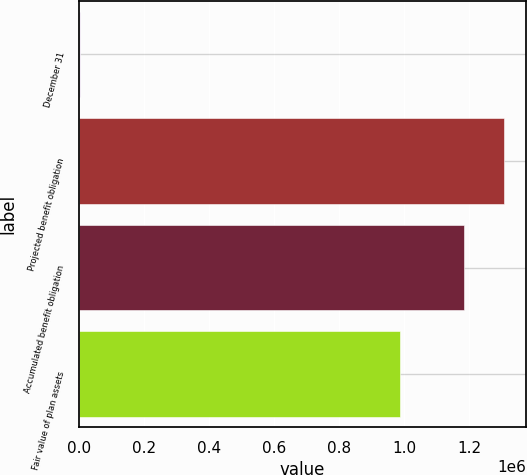Convert chart. <chart><loc_0><loc_0><loc_500><loc_500><bar_chart><fcel>December 31<fcel>Projected benefit obligation<fcel>Accumulated benefit obligation<fcel>Fair value of plan assets<nl><fcel>2012<fcel>1.30874e+06<fcel>1.18521e+06<fcel>987643<nl></chart> 